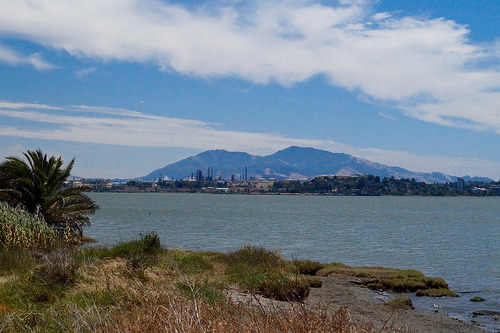<image>
Can you confirm if the mountain is on the lake? No. The mountain is not positioned on the lake. They may be near each other, but the mountain is not supported by or resting on top of the lake. Is there a water behind the mountain? No. The water is not behind the mountain. From this viewpoint, the water appears to be positioned elsewhere in the scene. Is there a mountain in front of the water? No. The mountain is not in front of the water. The spatial positioning shows a different relationship between these objects. 